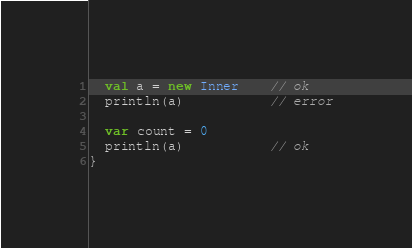Convert code to text. <code><loc_0><loc_0><loc_500><loc_500><_Scala_>  val a = new Inner    // ok
  println(a)           // error

  var count = 0
  println(a)           // ok
}</code> 